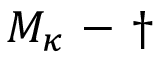Convert formula to latex. <formula><loc_0><loc_0><loc_500><loc_500>M _ { \kappa } - \dagger</formula> 